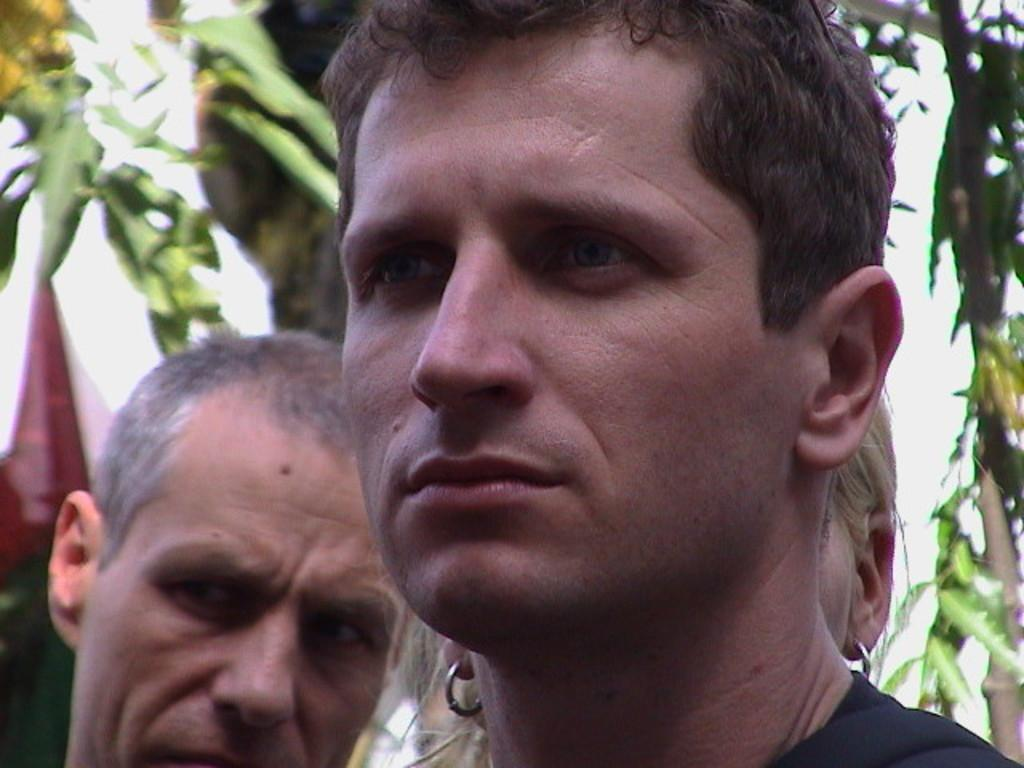How many people are present in the image? There are men in the image, so there are at least two people present. What type of toy can be seen on the bed in the image? There is no bed or toy present in the image; it only features men. 